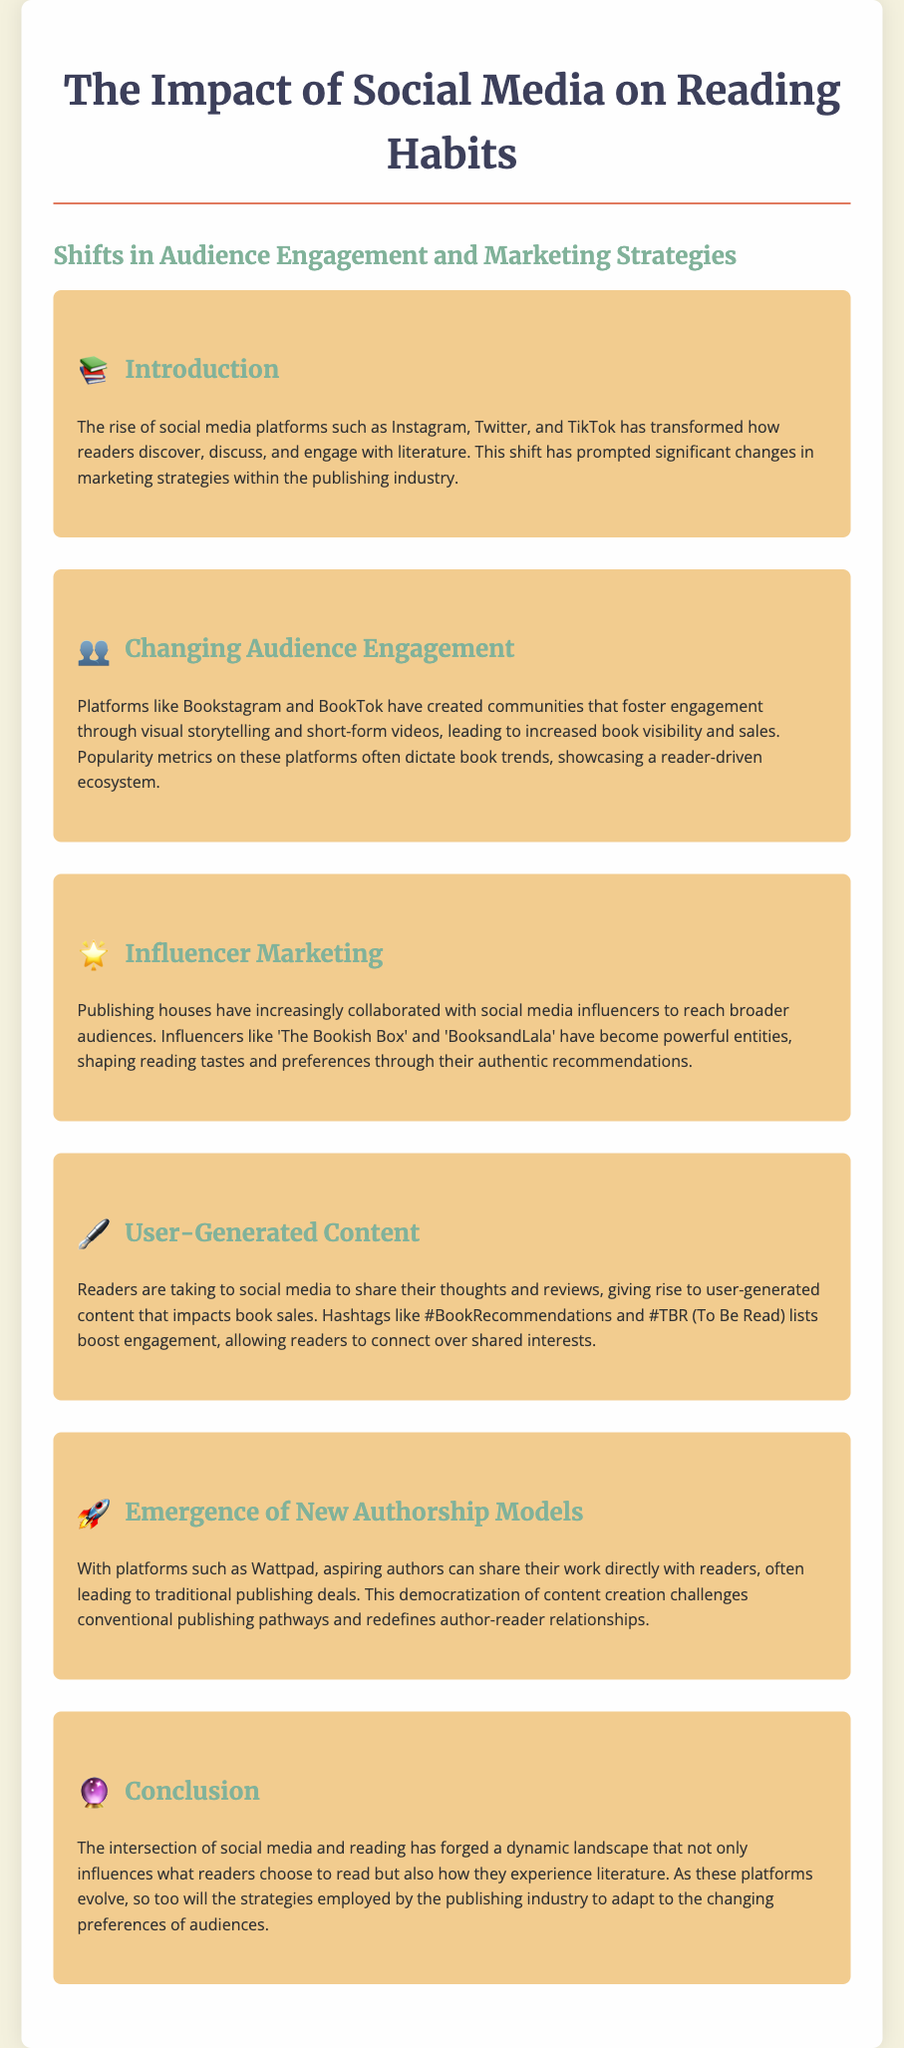What is the title of the document? The title is specified in the header section of the document and is “The Impact of Social Media on Reading Habits.”
Answer: The Impact of Social Media on Reading Habits Which social media platforms are mentioned in the introduction? The introduction lists Instagram, Twitter, and TikTok as the platforms transforming how readers engage with literature.
Answer: Instagram, Twitter, TikTok What type of marketing has seen an increase due to social media? The section on influencer marketing discusses how publishing houses collaborate with influencers to enhance their reach.
Answer: Influencer marketing What is a popular hashtag mentioned that boosts reader engagement? The user-generated content section highlights hashtags that readers use to share recommendations, specifically mentioning #BookRecommendations.
Answer: #BookRecommendations What effect do platforms like Bookstagram and BookTok have on books? The section on changing audience engagement states that these platforms lead to increased book visibility and sales.
Answer: Increased visibility and sales How has the relationship between authors and readers changed? The emergence of new authorship models addresses how platforms like Wattpad allow authors to connect directly with readers, altering traditional pathways.
Answer: Direct connection What new opportunity for authors does the document mention? The emergence of new authorship models discusses how aspiring authors can share their work directly, leading to traditional publishing deals.
Answer: Traditional publishing deals What is the main conclusion drawn about social media and reading? The conclusion summarizes that social media influences reader choices and literature experiences, causing changes in publishing strategies.
Answer: Influences reader choices and experiences 